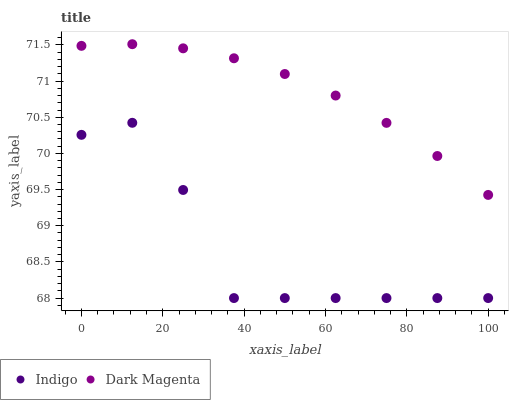Does Indigo have the minimum area under the curve?
Answer yes or no. Yes. Does Dark Magenta have the maximum area under the curve?
Answer yes or no. Yes. Does Dark Magenta have the minimum area under the curve?
Answer yes or no. No. Is Dark Magenta the smoothest?
Answer yes or no. Yes. Is Indigo the roughest?
Answer yes or no. Yes. Is Dark Magenta the roughest?
Answer yes or no. No. Does Indigo have the lowest value?
Answer yes or no. Yes. Does Dark Magenta have the lowest value?
Answer yes or no. No. Does Dark Magenta have the highest value?
Answer yes or no. Yes. Is Indigo less than Dark Magenta?
Answer yes or no. Yes. Is Dark Magenta greater than Indigo?
Answer yes or no. Yes. Does Indigo intersect Dark Magenta?
Answer yes or no. No. 